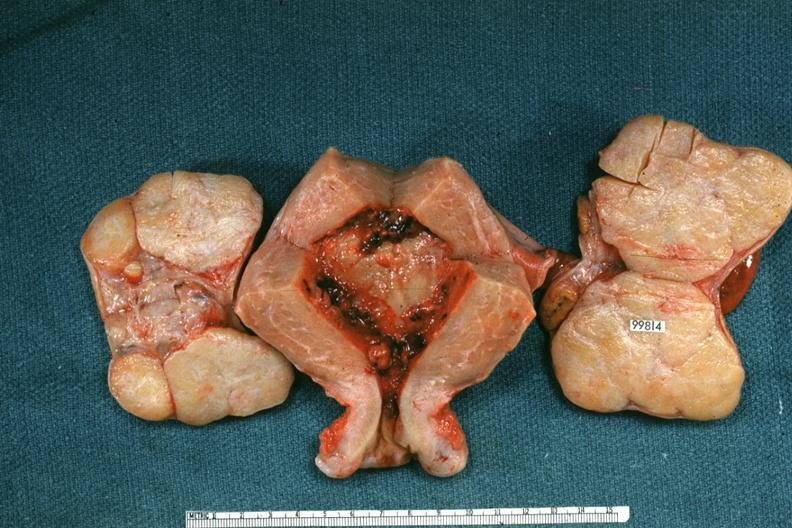what does this image show?
Answer the question using a single word or phrase. Uterus and ovaries with bilateral brenner tumors 